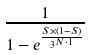<formula> <loc_0><loc_0><loc_500><loc_500>\frac { 1 } { 1 - e ^ { \frac { S \times ( 1 - S ) } { 3 ^ { N \cdot 1 } } } }</formula> 